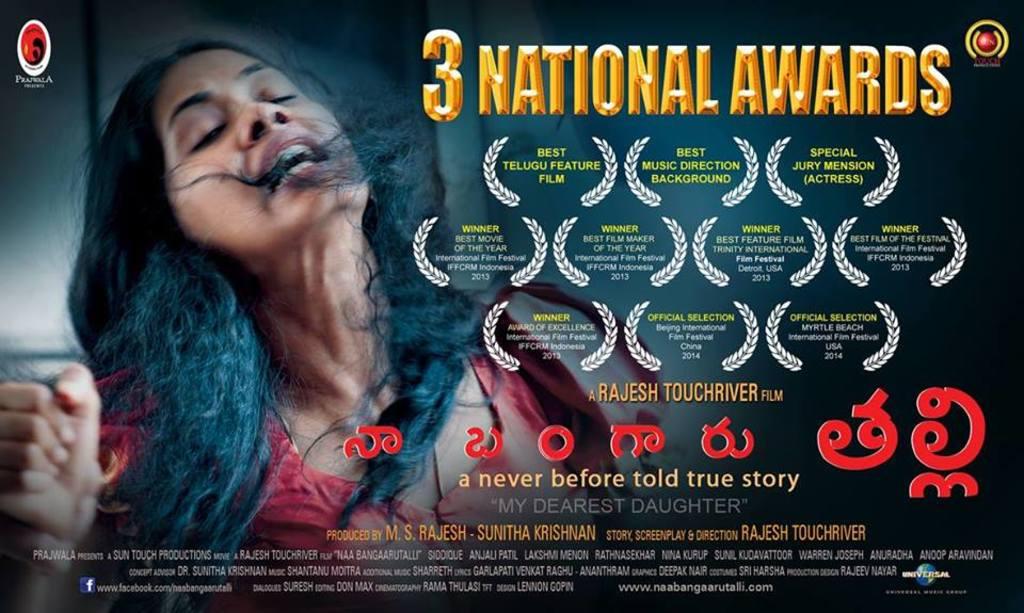What is the show name?
Keep it short and to the point. My dearest daughter. How many prizes has the show won?
Offer a very short reply. 3. 